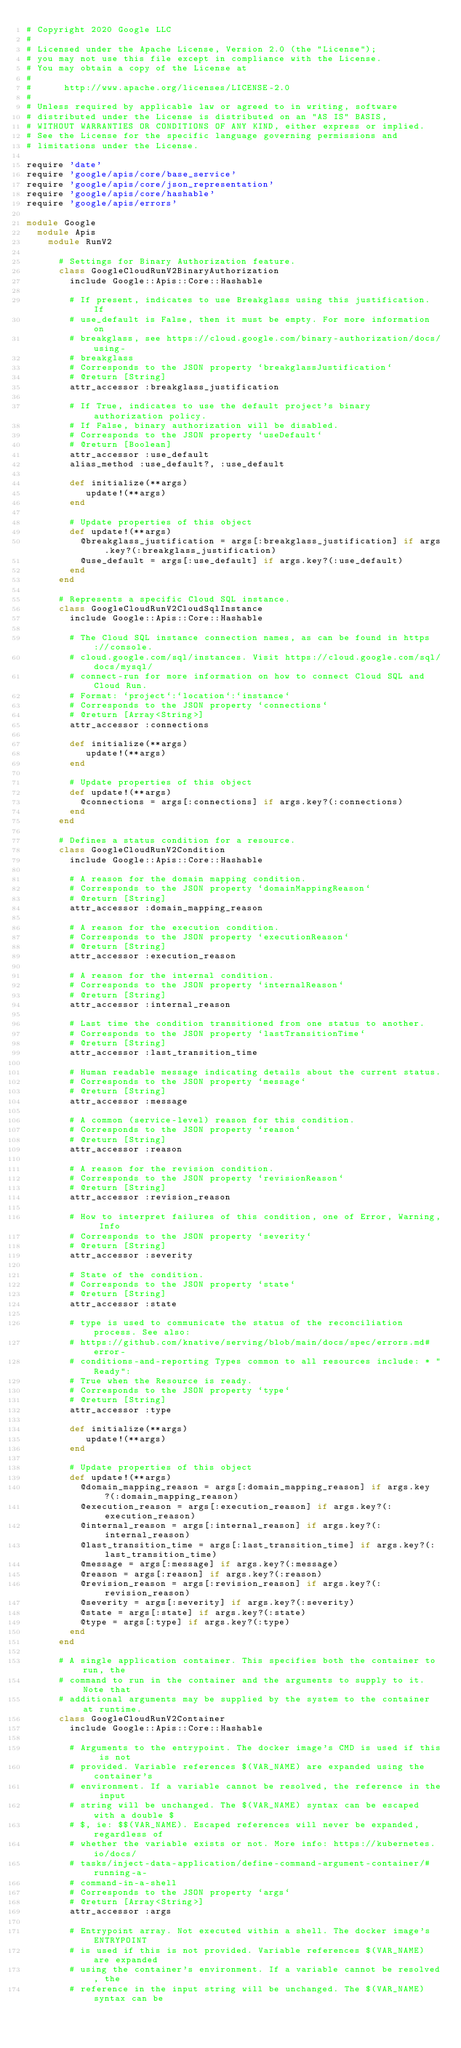Convert code to text. <code><loc_0><loc_0><loc_500><loc_500><_Ruby_># Copyright 2020 Google LLC
#
# Licensed under the Apache License, Version 2.0 (the "License");
# you may not use this file except in compliance with the License.
# You may obtain a copy of the License at
#
#      http://www.apache.org/licenses/LICENSE-2.0
#
# Unless required by applicable law or agreed to in writing, software
# distributed under the License is distributed on an "AS IS" BASIS,
# WITHOUT WARRANTIES OR CONDITIONS OF ANY KIND, either express or implied.
# See the License for the specific language governing permissions and
# limitations under the License.

require 'date'
require 'google/apis/core/base_service'
require 'google/apis/core/json_representation'
require 'google/apis/core/hashable'
require 'google/apis/errors'

module Google
  module Apis
    module RunV2
      
      # Settings for Binary Authorization feature.
      class GoogleCloudRunV2BinaryAuthorization
        include Google::Apis::Core::Hashable
      
        # If present, indicates to use Breakglass using this justification. If
        # use_default is False, then it must be empty. For more information on
        # breakglass, see https://cloud.google.com/binary-authorization/docs/using-
        # breakglass
        # Corresponds to the JSON property `breakglassJustification`
        # @return [String]
        attr_accessor :breakglass_justification
      
        # If True, indicates to use the default project's binary authorization policy.
        # If False, binary authorization will be disabled.
        # Corresponds to the JSON property `useDefault`
        # @return [Boolean]
        attr_accessor :use_default
        alias_method :use_default?, :use_default
      
        def initialize(**args)
           update!(**args)
        end
      
        # Update properties of this object
        def update!(**args)
          @breakglass_justification = args[:breakglass_justification] if args.key?(:breakglass_justification)
          @use_default = args[:use_default] if args.key?(:use_default)
        end
      end
      
      # Represents a specific Cloud SQL instance.
      class GoogleCloudRunV2CloudSqlInstance
        include Google::Apis::Core::Hashable
      
        # The Cloud SQL instance connection names, as can be found in https://console.
        # cloud.google.com/sql/instances. Visit https://cloud.google.com/sql/docs/mysql/
        # connect-run for more information on how to connect Cloud SQL and Cloud Run.
        # Format: `project`:`location`:`instance`
        # Corresponds to the JSON property `connections`
        # @return [Array<String>]
        attr_accessor :connections
      
        def initialize(**args)
           update!(**args)
        end
      
        # Update properties of this object
        def update!(**args)
          @connections = args[:connections] if args.key?(:connections)
        end
      end
      
      # Defines a status condition for a resource.
      class GoogleCloudRunV2Condition
        include Google::Apis::Core::Hashable
      
        # A reason for the domain mapping condition.
        # Corresponds to the JSON property `domainMappingReason`
        # @return [String]
        attr_accessor :domain_mapping_reason
      
        # A reason for the execution condition.
        # Corresponds to the JSON property `executionReason`
        # @return [String]
        attr_accessor :execution_reason
      
        # A reason for the internal condition.
        # Corresponds to the JSON property `internalReason`
        # @return [String]
        attr_accessor :internal_reason
      
        # Last time the condition transitioned from one status to another.
        # Corresponds to the JSON property `lastTransitionTime`
        # @return [String]
        attr_accessor :last_transition_time
      
        # Human readable message indicating details about the current status.
        # Corresponds to the JSON property `message`
        # @return [String]
        attr_accessor :message
      
        # A common (service-level) reason for this condition.
        # Corresponds to the JSON property `reason`
        # @return [String]
        attr_accessor :reason
      
        # A reason for the revision condition.
        # Corresponds to the JSON property `revisionReason`
        # @return [String]
        attr_accessor :revision_reason
      
        # How to interpret failures of this condition, one of Error, Warning, Info
        # Corresponds to the JSON property `severity`
        # @return [String]
        attr_accessor :severity
      
        # State of the condition.
        # Corresponds to the JSON property `state`
        # @return [String]
        attr_accessor :state
      
        # type is used to communicate the status of the reconciliation process. See also:
        # https://github.com/knative/serving/blob/main/docs/spec/errors.md#error-
        # conditions-and-reporting Types common to all resources include: * "Ready":
        # True when the Resource is ready.
        # Corresponds to the JSON property `type`
        # @return [String]
        attr_accessor :type
      
        def initialize(**args)
           update!(**args)
        end
      
        # Update properties of this object
        def update!(**args)
          @domain_mapping_reason = args[:domain_mapping_reason] if args.key?(:domain_mapping_reason)
          @execution_reason = args[:execution_reason] if args.key?(:execution_reason)
          @internal_reason = args[:internal_reason] if args.key?(:internal_reason)
          @last_transition_time = args[:last_transition_time] if args.key?(:last_transition_time)
          @message = args[:message] if args.key?(:message)
          @reason = args[:reason] if args.key?(:reason)
          @revision_reason = args[:revision_reason] if args.key?(:revision_reason)
          @severity = args[:severity] if args.key?(:severity)
          @state = args[:state] if args.key?(:state)
          @type = args[:type] if args.key?(:type)
        end
      end
      
      # A single application container. This specifies both the container to run, the
      # command to run in the container and the arguments to supply to it. Note that
      # additional arguments may be supplied by the system to the container at runtime.
      class GoogleCloudRunV2Container
        include Google::Apis::Core::Hashable
      
        # Arguments to the entrypoint. The docker image's CMD is used if this is not
        # provided. Variable references $(VAR_NAME) are expanded using the container's
        # environment. If a variable cannot be resolved, the reference in the input
        # string will be unchanged. The $(VAR_NAME) syntax can be escaped with a double $
        # $, ie: $$(VAR_NAME). Escaped references will never be expanded, regardless of
        # whether the variable exists or not. More info: https://kubernetes.io/docs/
        # tasks/inject-data-application/define-command-argument-container/#running-a-
        # command-in-a-shell
        # Corresponds to the JSON property `args`
        # @return [Array<String>]
        attr_accessor :args
      
        # Entrypoint array. Not executed within a shell. The docker image's ENTRYPOINT
        # is used if this is not provided. Variable references $(VAR_NAME) are expanded
        # using the container's environment. If a variable cannot be resolved, the
        # reference in the input string will be unchanged. The $(VAR_NAME) syntax can be</code> 